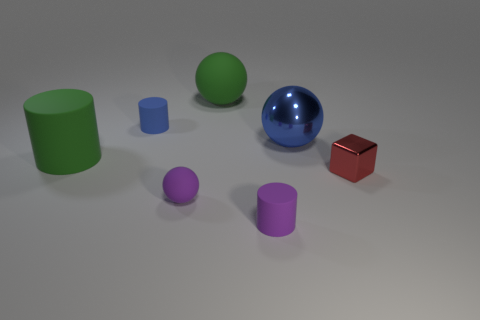Subtract all green rubber balls. How many balls are left? 2 Add 3 large blue shiny spheres. How many objects exist? 10 Subtract all yellow spheres. Subtract all green cylinders. How many spheres are left? 3 Subtract 0 red balls. How many objects are left? 7 Subtract all spheres. How many objects are left? 4 Subtract all purple spheres. Subtract all big rubber objects. How many objects are left? 4 Add 1 large balls. How many large balls are left? 3 Add 2 small purple rubber things. How many small purple rubber things exist? 4 